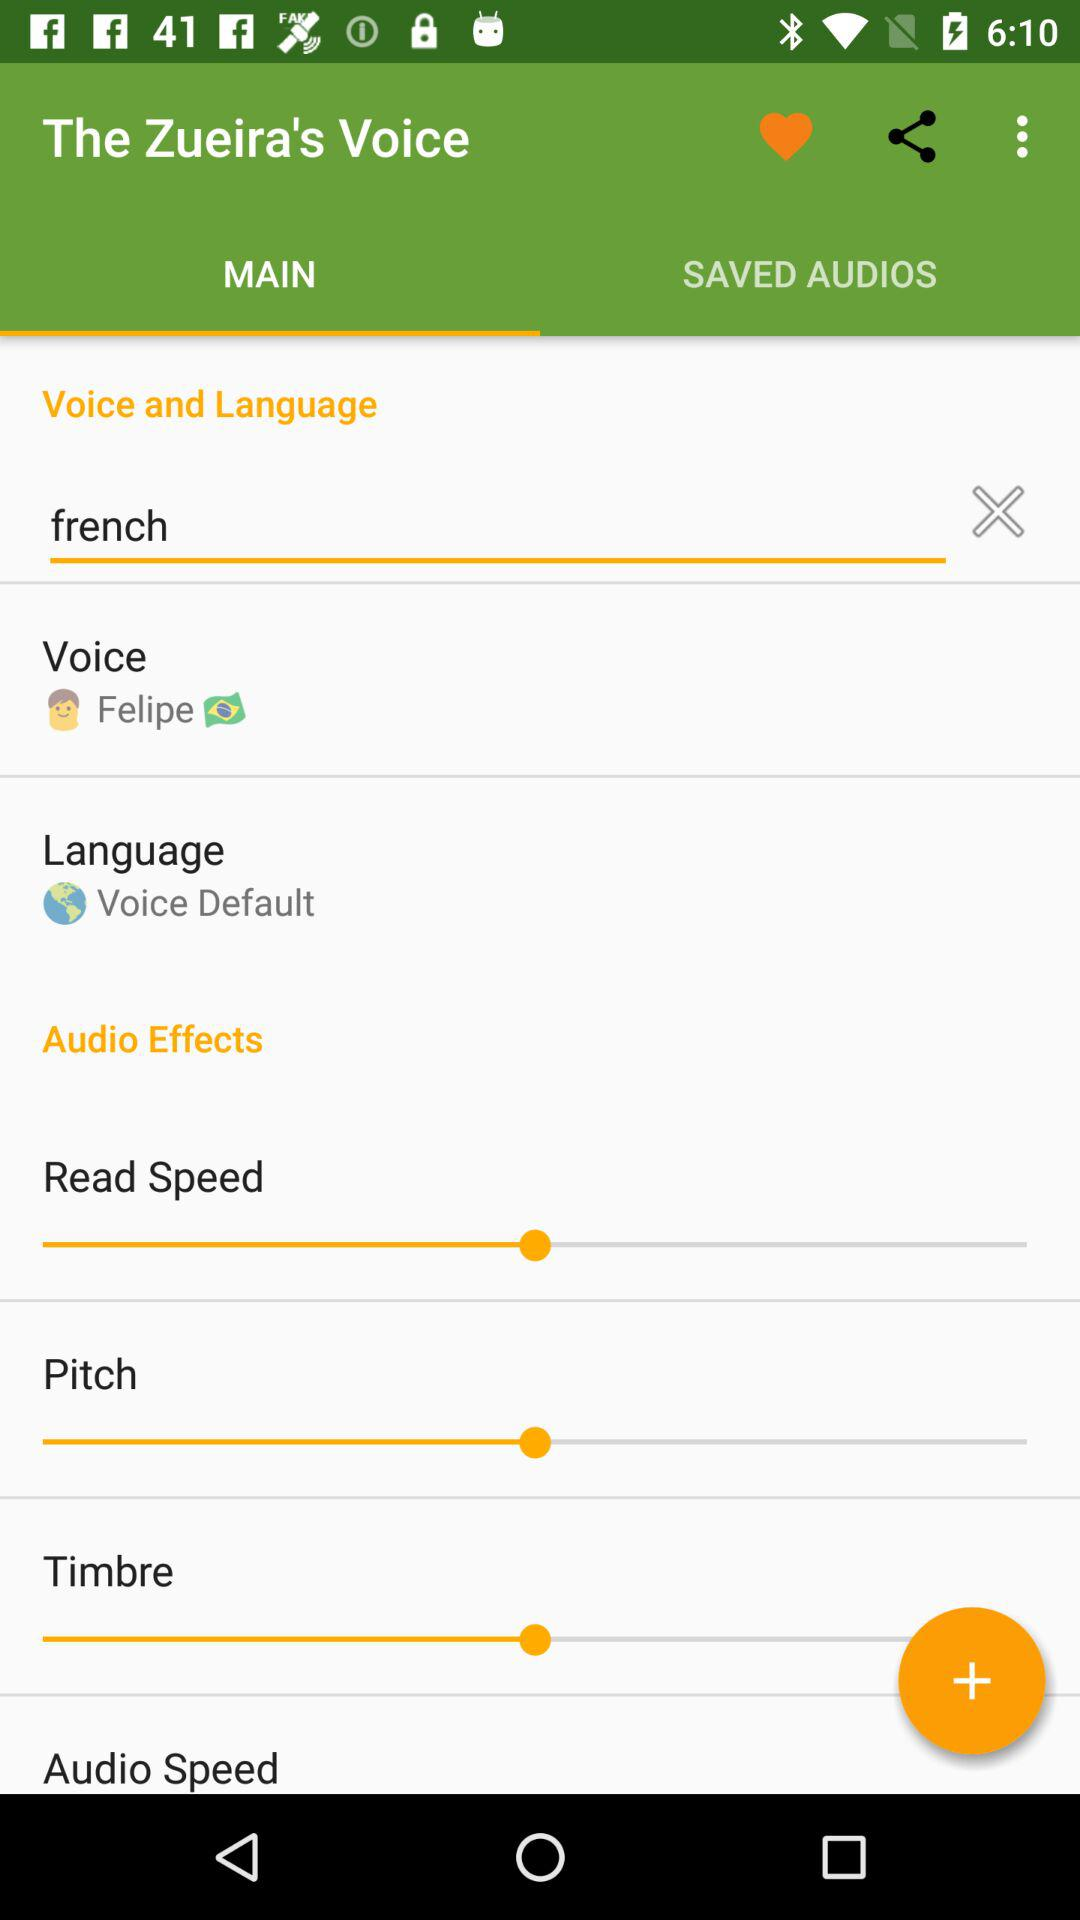What language has been selected? The selected language is Voice Default. 